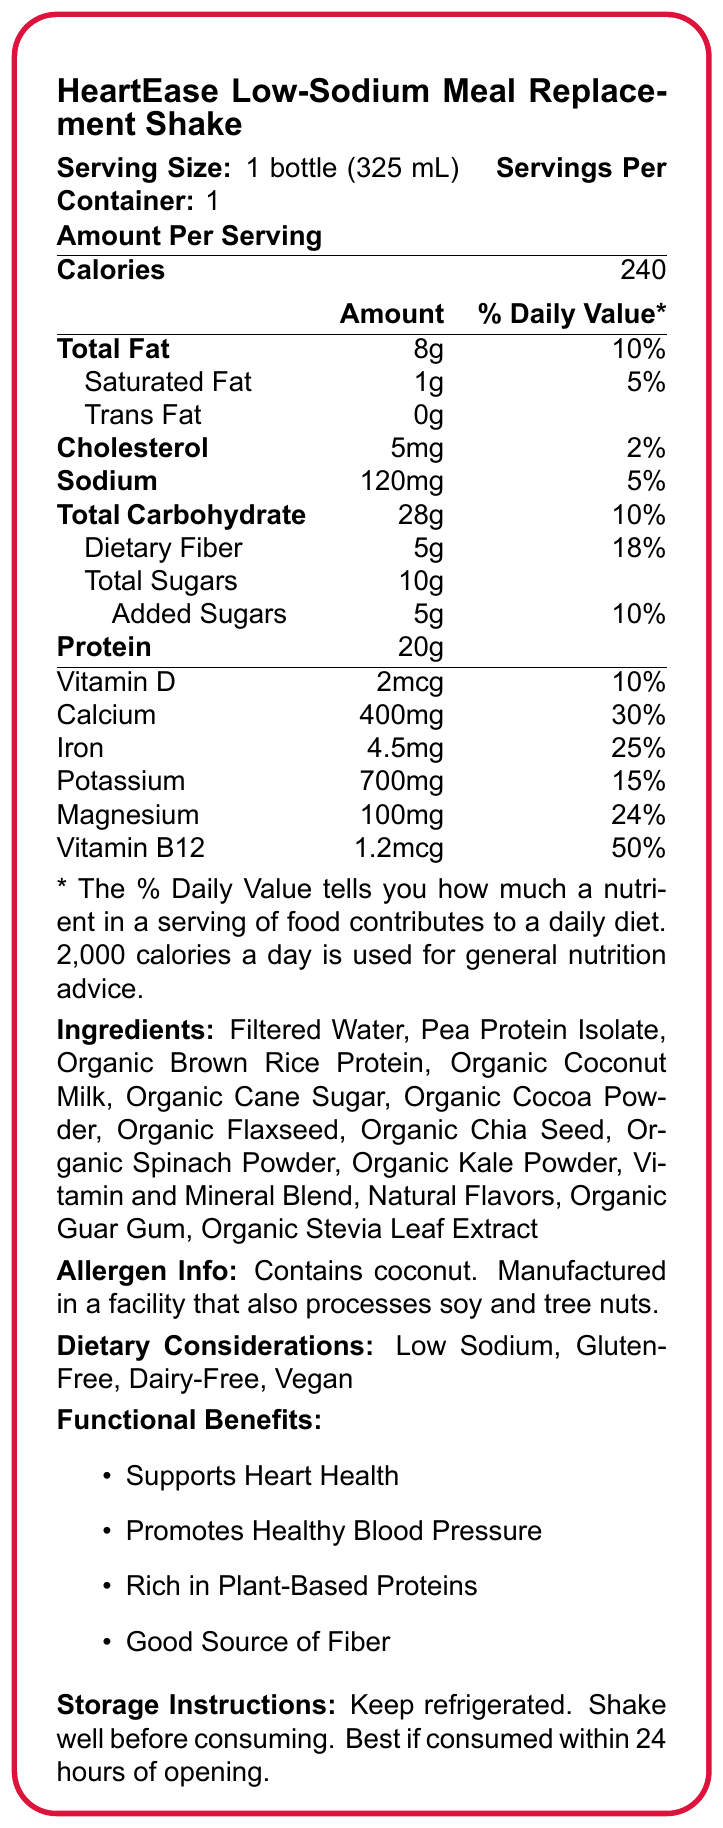what is the serving size for HeartEase Low-Sodium Meal Replacement Shake? The document states that the serving size is 1 bottle, which is equivalent to 325 mL.
Answer: 1 bottle (325 mL) how many calories are in each serving? The nutrition facts label mentions that each serving contains 240 calories.
Answer: 240 what percent of the daily value for protein does this shake provide? The document does not provide the percent daily value for protein.
Answer: Not listed what is the total fat content per serving? The document indicates that each serving has 8g of total fat.
Answer: 8g how much sodium does one serving contain? The document shows that one serving contains 120mg of sodium.
Answer: 120mg which ingredient is listed first in the ingredients list? A. Organic Cocoa Powder B. Organic Coconut Milk C. Filtered Water The ingredients list starts with Filtered Water as its first ingredient.
Answer: C. Filtered Water what percent of the daily value of calcium does this shake provide? The label states that each serving provides 30% of the daily value for calcium.
Answer: 30% is the product gluten-free? The dietary considerations section mentions that the product is Gluten-Free.
Answer: Yes does this product contain any trans fat? The nutrition facts label shows 0g of trans fat.
Answer: No how much dietary fiber is in one serving? The label shows that one serving contains 5g of dietary fiber.
Answer: 5g which of the following is NOT a functional benefit of the shake? I. Supports Heart Health II. Promotes Weight Loss III. Rich in Plant-Based Proteins IV. Good Source of Fiber The functional benefits listed on the document are Supports Heart Health, Promotes Healthy Blood Pressure, Rich in Plant-Based Proteins, and Good Source of Fiber. Promotes Weight Loss is not mentioned.
Answer: II. Promotes Weight Loss what are the dietary considerations for this product? A. Low Sodium, Gluten-Free, Dairy-Free, Vegan B. Low Sodium, Low Sugar, Dairy-Free, Vegetarian C. Low Sodium, High Protein, Gluten-Free, Vegan The dietary considerations section lists Low Sodium, Gluten-Free, Dairy-Free, and Vegan.
Answer: A. Low Sodium, Gluten-Free, Dairy-Free, Vegan does this product support heart health? One of the functional benefits listed is that it supports heart health.
Answer: Yes what is the storage instruction for HeartEase Low-Sodium Meal Replacement Shake? The document lists the storage instructions as keeping it refrigerated, shaking well before consuming, and that it's best if consumed within 24 hours of opening.
Answer: Keep refrigerated. Shake well before consuming. Best if consumed within 24 hours of opening. summarize the key nutritional and functional information of HeartEase Low-Sodium Meal Replacement Shake. This summary comprehensively includes nutritional content, functional benefits, and storage instructions as provided by the document.
Answer: HeartEase Low-Sodium Meal Replacement Shake is a meal replacement drink with 240 calories per serving. It contains 8g of total fat, 1g of saturated fat, and 0g of trans fat. Each serving provides 20g of protein, 120mg of sodium, 28g of carbohydrates, and 5g of dietary fiber. It includes vitamins and minerals like calcium, iron, potassium, magnesium, and vitamin B12. The shake is low sodium, gluten-free, dairy-free, and vegan. Functional benefits include supporting heart health, promoting healthy blood pressure, being rich in plant-based proteins, and being a good source of fiber. It should be kept refrigerated and consumed within 24 hours of opening. what is the source of iron in this product? The document does not provide specific information on the source of iron in the product.
Answer: Not enough information 